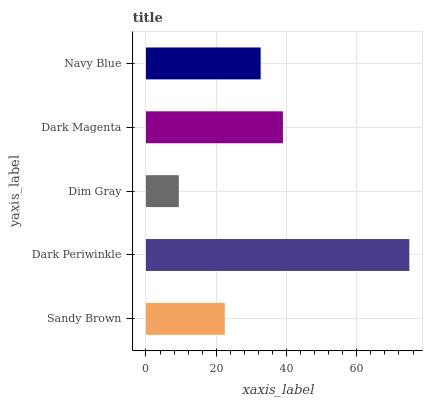Is Dim Gray the minimum?
Answer yes or no. Yes. Is Dark Periwinkle the maximum?
Answer yes or no. Yes. Is Dark Periwinkle the minimum?
Answer yes or no. No. Is Dim Gray the maximum?
Answer yes or no. No. Is Dark Periwinkle greater than Dim Gray?
Answer yes or no. Yes. Is Dim Gray less than Dark Periwinkle?
Answer yes or no. Yes. Is Dim Gray greater than Dark Periwinkle?
Answer yes or no. No. Is Dark Periwinkle less than Dim Gray?
Answer yes or no. No. Is Navy Blue the high median?
Answer yes or no. Yes. Is Navy Blue the low median?
Answer yes or no. Yes. Is Sandy Brown the high median?
Answer yes or no. No. Is Sandy Brown the low median?
Answer yes or no. No. 